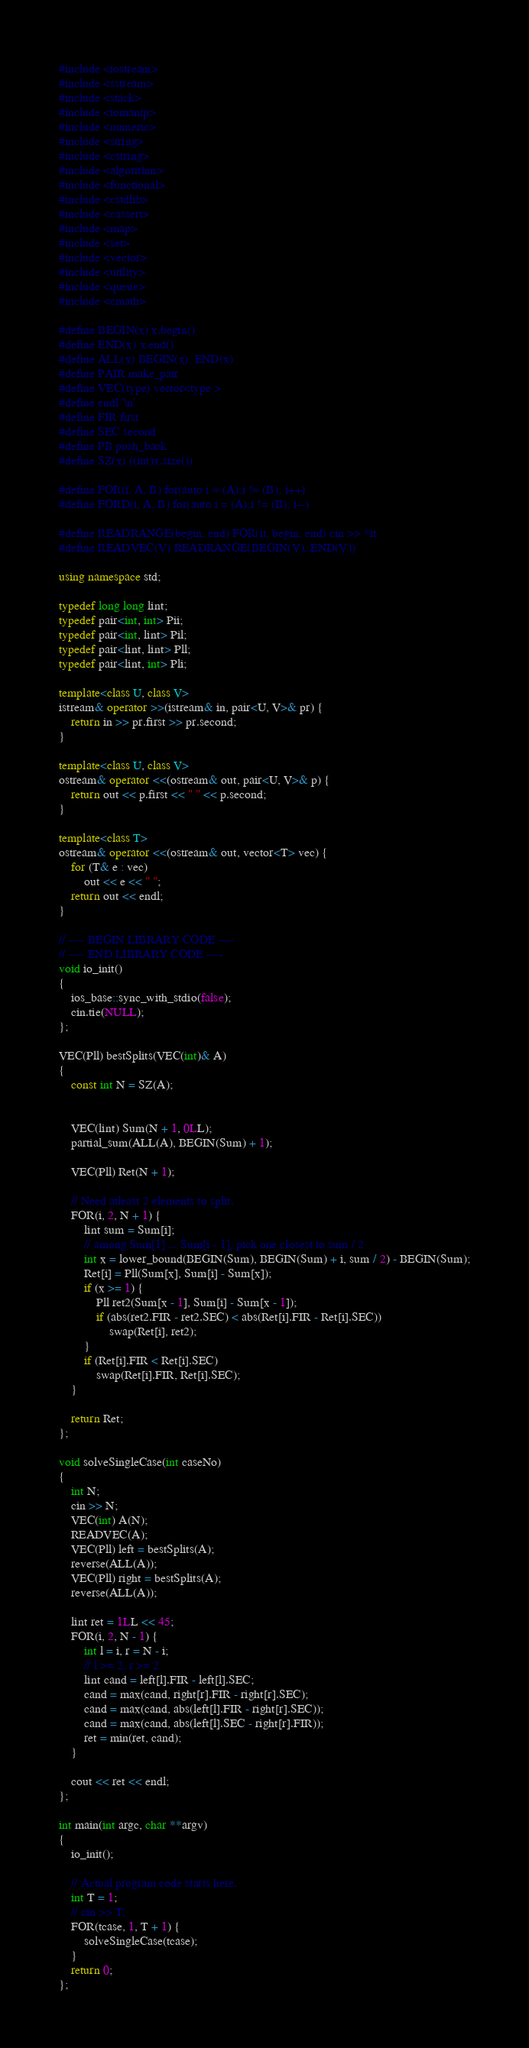<code> <loc_0><loc_0><loc_500><loc_500><_C++_>#include <iostream>
#include <sstream>
#include <stack>
#include <iomanip>
#include <numeric>
#include <string>
#include <cstring>
#include <algorithm>
#include <functional>
#include <cstdlib>
#include <cassert>
#include <map>
#include <set>
#include <vector>
#include <utility>
#include <queue>
#include <cmath>

#define BEGIN(x) x.begin()
#define END(x) x.end()
#define ALL(x) BEGIN(x), END(x)
#define PAIR make_pair
#define VEC(type) vector<type >
#define endl '\n'
#define FIR first
#define SEC second
#define PB push_back
#define SZ(x) ((int)x.size())

#define FOR(i, A, B) for(auto i = (A);i != (B); i++)
#define FORD(i, A, B) for(auto i = (A);i != (B); i--)

#define READRANGE(begin, end) FOR(it, begin, end) cin >> *it
#define READVEC(V) READRANGE(BEGIN(V), END(V))

using namespace std;

typedef long long lint;
typedef pair<int, int> Pii;
typedef pair<int, lint> Pil;
typedef pair<lint, lint> Pll;
typedef pair<lint, int> Pli;

template<class U, class V>
istream& operator >>(istream& in, pair<U, V>& pr) {
    return in >> pr.first >> pr.second;
}

template<class U, class V>
ostream& operator <<(ostream& out, pair<U, V>& p) {
    return out << p.first << " " << p.second;
}

template<class T>
ostream& operator <<(ostream& out, vector<T> vec) {
    for (T& e : vec)
        out << e << " ";
    return out << endl;
}

// ---- BEGIN LIBRARY CODE ----
// ---- END LIBRARY CODE ----
void io_init()
{
    ios_base::sync_with_stdio(false);
    cin.tie(NULL);
};

VEC(Pll) bestSplits(VEC(int)& A)
{
    const int N = SZ(A);


    VEC(lint) Sum(N + 1, 0LL);
    partial_sum(ALL(A), BEGIN(Sum) + 1);

    VEC(Pll) Ret(N + 1);

    // Need atleast 2 elements to split.
    FOR(i, 2, N + 1) {
        lint sum = Sum[i];
        // among Sum[1] ... Sum[i - 1], pick one closest to sum / 2
        int x = lower_bound(BEGIN(Sum), BEGIN(Sum) + i, sum / 2) - BEGIN(Sum);
        Ret[i] = Pll(Sum[x], Sum[i] - Sum[x]);
        if (x >= 1) {
            Pll ret2(Sum[x - 1], Sum[i] - Sum[x - 1]);
            if (abs(ret2.FIR - ret2.SEC) < abs(Ret[i].FIR - Ret[i].SEC))
                swap(Ret[i], ret2);
        }
        if (Ret[i].FIR < Ret[i].SEC)
            swap(Ret[i].FIR, Ret[i].SEC);
    }

    return Ret;
};

void solveSingleCase(int caseNo)
{
    int N;
    cin >> N;
    VEC(int) A(N);
    READVEC(A);
    VEC(Pll) left = bestSplits(A);
    reverse(ALL(A));
    VEC(Pll) right = bestSplits(A);
    reverse(ALL(A));

    lint ret = 1LL << 45;
    FOR(i, 2, N - 1) {
        int l = i, r = N - i;
        // l >= 2, r >= 2
        lint cand = left[l].FIR - left[l].SEC;
        cand = max(cand, right[r].FIR - right[r].SEC);
        cand = max(cand, abs(left[l].FIR - right[r].SEC));
        cand = max(cand, abs(left[l].SEC - right[r].FIR));
        ret = min(ret, cand);
    }

    cout << ret << endl;
};

int main(int argc, char **argv)
{
    io_init();

    // Actual program code starts here.
    int T = 1;
    // cin >> T;
    FOR(tcase, 1, T + 1) {
        solveSingleCase(tcase);
    }
    return 0;
};
</code> 